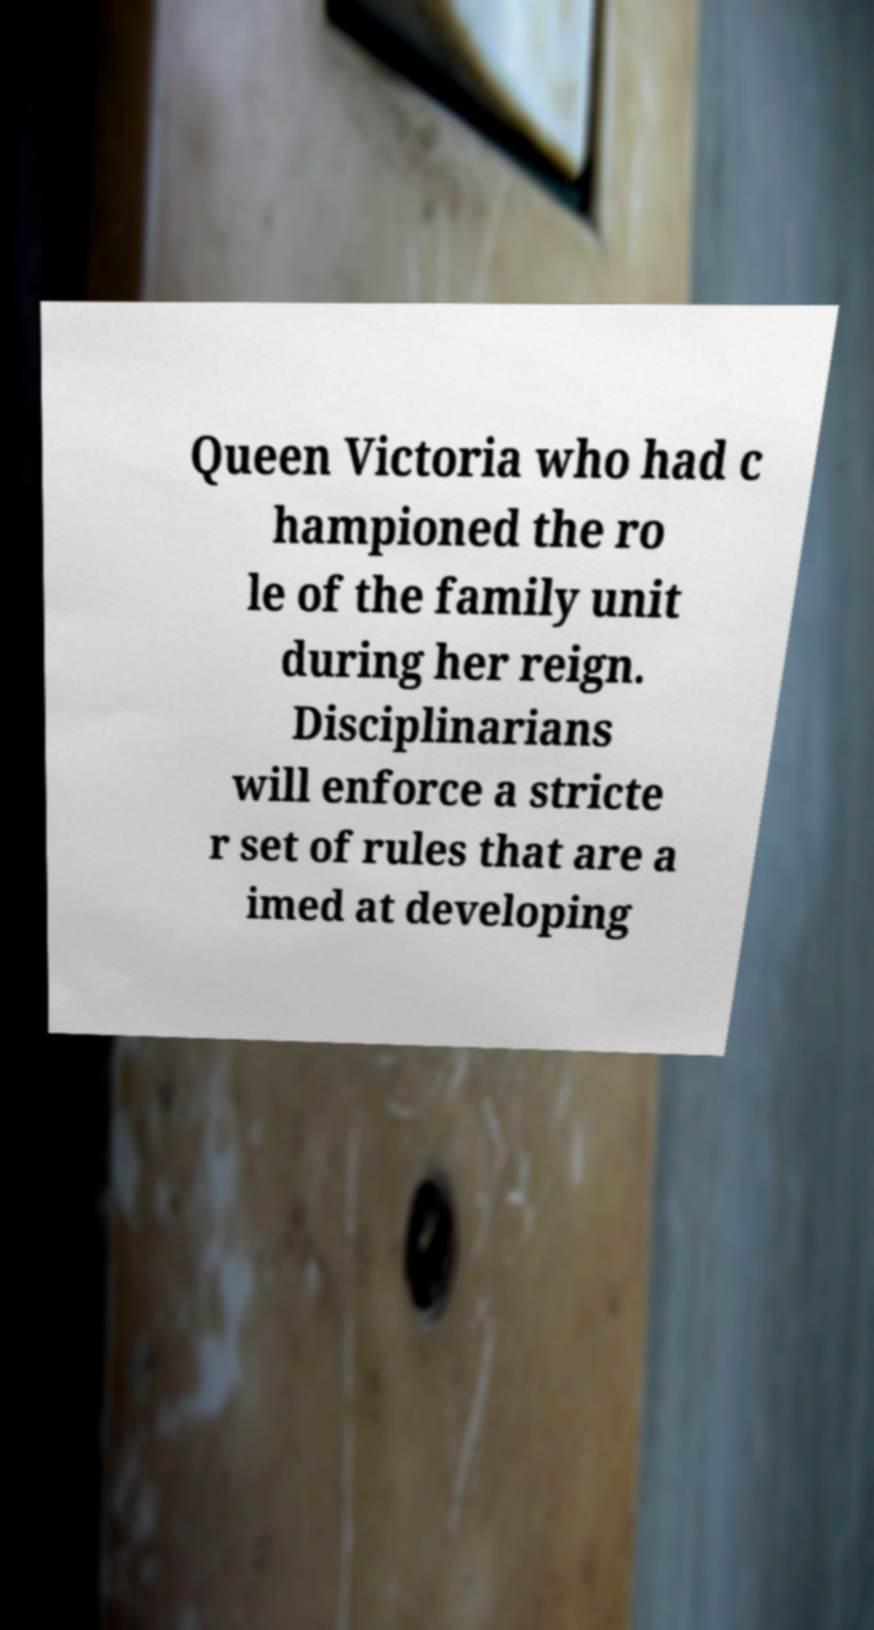Could you extract and type out the text from this image? Queen Victoria who had c hampioned the ro le of the family unit during her reign. Disciplinarians will enforce a stricte r set of rules that are a imed at developing 